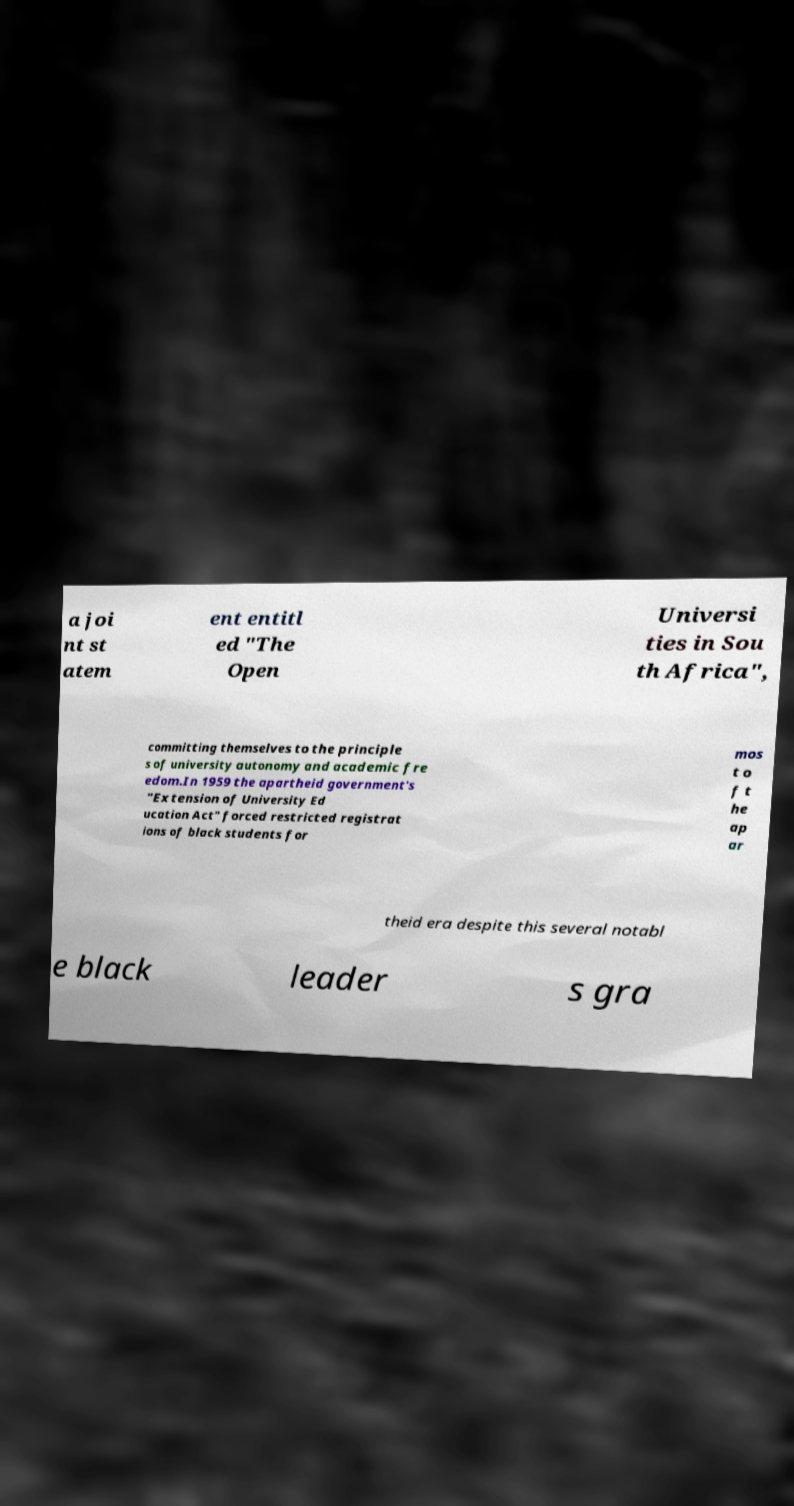Could you assist in decoding the text presented in this image and type it out clearly? a joi nt st atem ent entitl ed "The Open Universi ties in Sou th Africa", committing themselves to the principle s of university autonomy and academic fre edom.In 1959 the apartheid government's "Extension of University Ed ucation Act" forced restricted registrat ions of black students for mos t o f t he ap ar theid era despite this several notabl e black leader s gra 